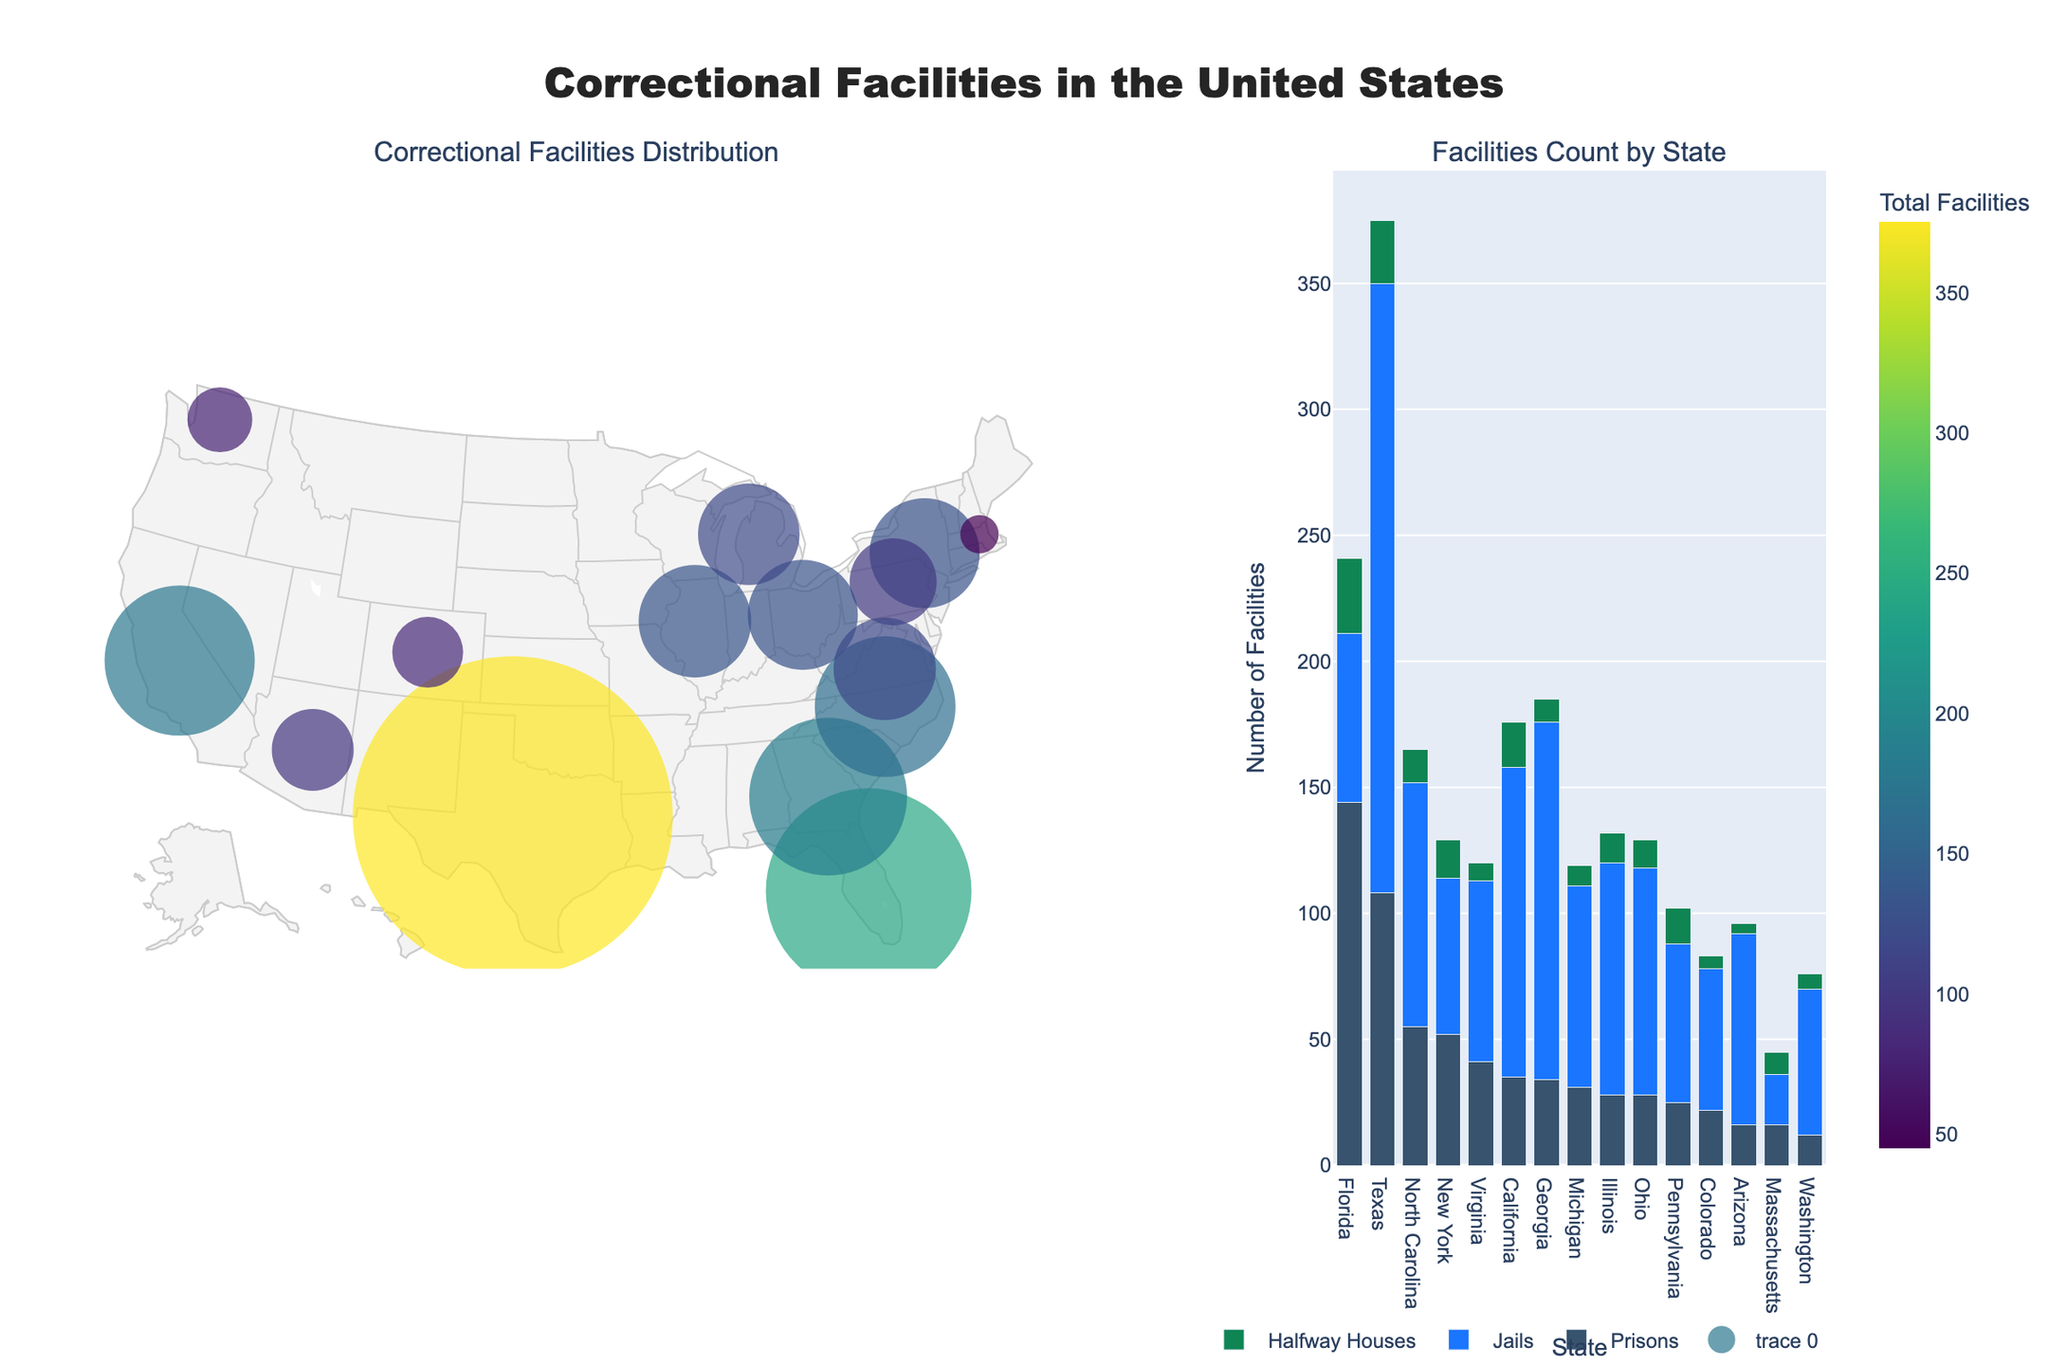What is the total number of correctional facilities in Texas? To determine the total number of correctional facilities in Texas, sum the number of prisons, jails, and halfway houses as shown in the plot. Texas has 108 prisons, 242 jails, and 25 halfway houses. Adding these gives 108 + 242 + 25 = 375.
Answer: 375 Which state has the highest number of prisons? By examining the bar chart part of the figure, the state with the tallest bar within the 'Prisons' category will have the highest number of prisons. Florida has the highest number of prisons with 144.
Answer: Florida How does the number of jails in Illinois compare to that in North Carolina? Observe the height of the bars corresponding to 'Jails' for both Illinois and North Carolina in the bar chart. Illinois has 92 jails, while North Carolina has 97.
Answer: North Carolina has more jails than Illinois Which state has the smallest number of halfway houses, and what is that number? Identify the state with the shortest bar in the 'Halfway Houses' category in the bar chart. Arizona has the smallest number of halfway houses, which is 4.
Answer: Arizona, 4 What is the average number of jails across all states depicted in the plot? To find the average number of jails, sum the number of jails for all states and divide by the number of states. Summing the jails: 123+242+67+62+92+63+90+142+80+97+72+58+56+76+20 = 1340. There are 15 states, so the average is 1340 / 15 = 89.3.
Answer: 89.3 Which states have more than 50 prisons each? In the bar chart, look for states with bar heights greater than 50 in the 'Prisons' category. Florida (144), Texas (108), North Carolina (55), New York (52) each have more than 50 prisons.
Answer: Florida, Texas, North Carolina, New York Are there any states that have fewer than 10 halfway houses and more than 50 jails? Examine the bar chart for states that meet both conditions. Arizona (4 halfway houses, 76 jails) and Michigan (8 halfway houses, 80 jails) fit this criterion.
Answer: Arizona, Michigan What is the title of the plot? Read the title text at the top of the figure in the middle.
Answer: Correctional Facilities in the United States Which state has the lowest total number of correctional facilities, and how many are there? In the geographic plot, find the state with the smallest marker size, which indicates the total number of facilities is the lowest. Massachusetts has the smallest total with 45 facilities.
Answer: Massachusetts, 45 